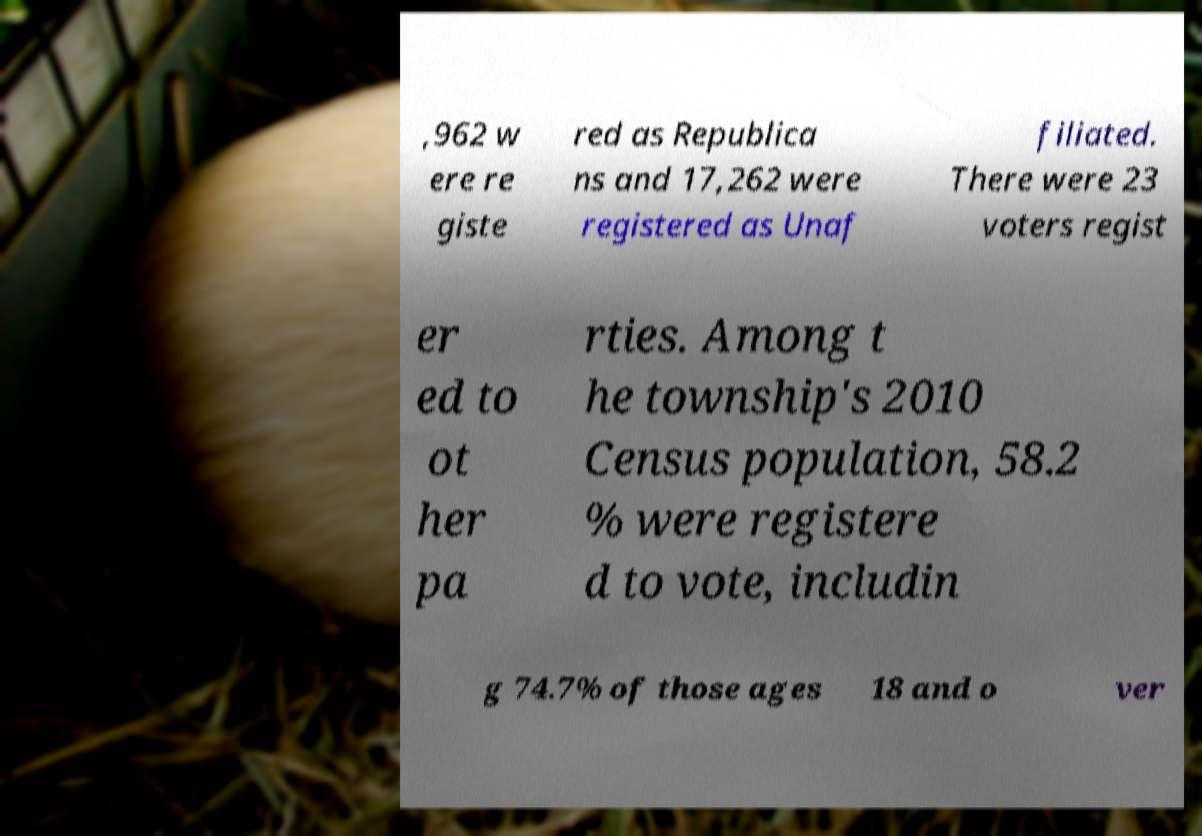Could you extract and type out the text from this image? ,962 w ere re giste red as Republica ns and 17,262 were registered as Unaf filiated. There were 23 voters regist er ed to ot her pa rties. Among t he township's 2010 Census population, 58.2 % were registere d to vote, includin g 74.7% of those ages 18 and o ver 